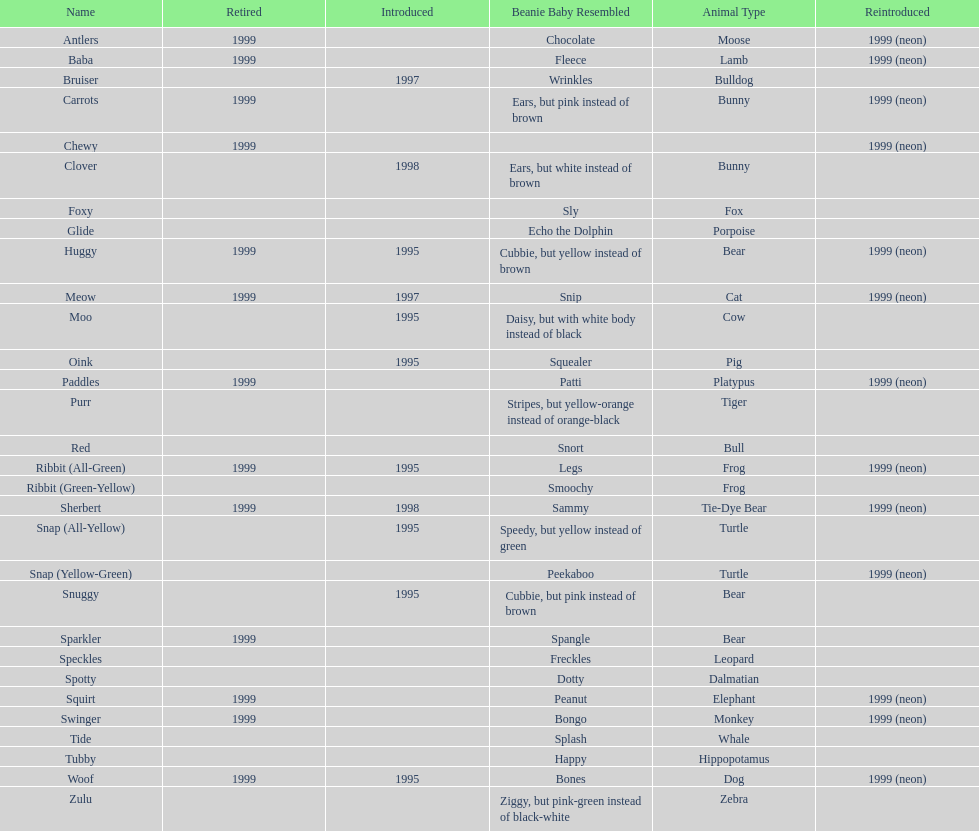Which is the only pillow pal without a listed animal type? Chewy. 